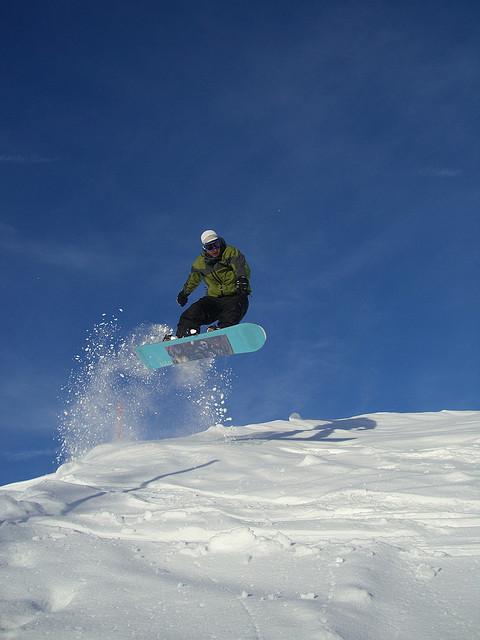Is the person sitting on a surfboard?
Give a very brief answer. No. Is this person snowboarding?
Be succinct. Yes. What color is the snow under the board?
Give a very brief answer. White. What color is the board?
Concise answer only. Blue. What happens if the snowboarding misses his spot upon landing?
Short answer required. Fall. Is the man snowboarding?
Be succinct. Yes. Is this a desert?
Be succinct. No. What color are the snow pants?
Concise answer only. Black. Is the person snowboarding?
Quick response, please. Yes. What sport is this?
Short answer required. Snowboarding. 